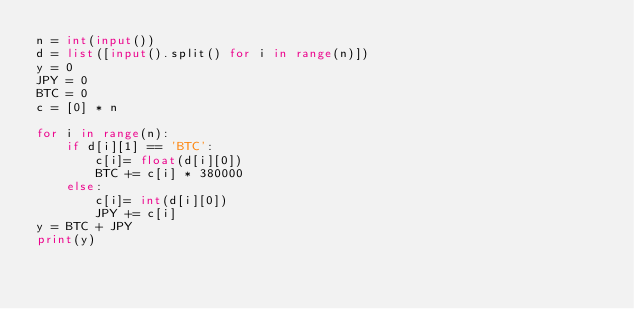<code> <loc_0><loc_0><loc_500><loc_500><_Python_>n = int(input())
d = list([input().split() for i in range(n)])
y = 0
JPY = 0
BTC = 0
c = [0] * n

for i in range(n):
    if d[i][1] == 'BTC':
        c[i]= float(d[i][0])
        BTC += c[i] * 380000
    else:
        c[i]= int(d[i][0])
        JPY += c[i]
y = BTC + JPY
print(y)
</code> 